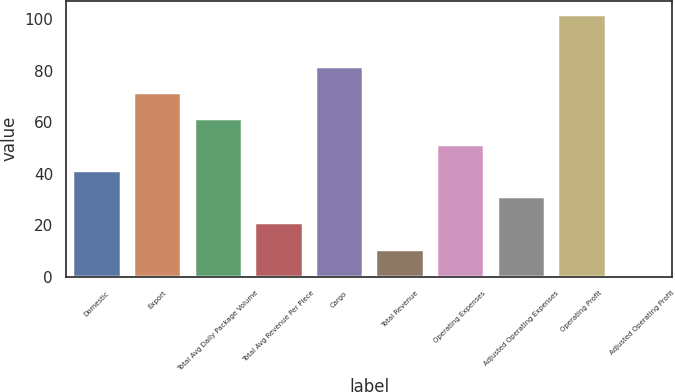Convert chart. <chart><loc_0><loc_0><loc_500><loc_500><bar_chart><fcel>Domestic<fcel>Export<fcel>Total Avg Daily Package Volume<fcel>Total Avg Revenue Per Piece<fcel>Cargo<fcel>Total Revenue<fcel>Operating Expenses<fcel>Adjusted Operating Expenses<fcel>Operating Profit<fcel>Adjusted Operating Profit<nl><fcel>41.36<fcel>71.78<fcel>61.64<fcel>21.08<fcel>81.92<fcel>10.94<fcel>51.5<fcel>31.22<fcel>102.2<fcel>0.8<nl></chart> 